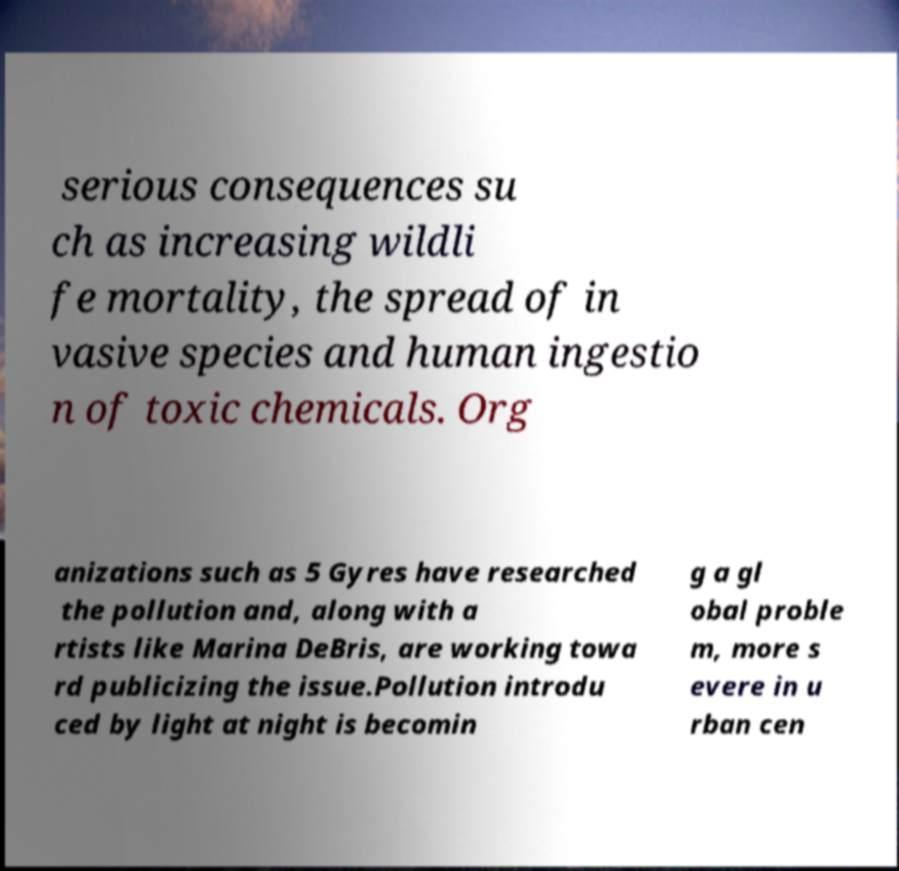Could you extract and type out the text from this image? serious consequences su ch as increasing wildli fe mortality, the spread of in vasive species and human ingestio n of toxic chemicals. Org anizations such as 5 Gyres have researched the pollution and, along with a rtists like Marina DeBris, are working towa rd publicizing the issue.Pollution introdu ced by light at night is becomin g a gl obal proble m, more s evere in u rban cen 